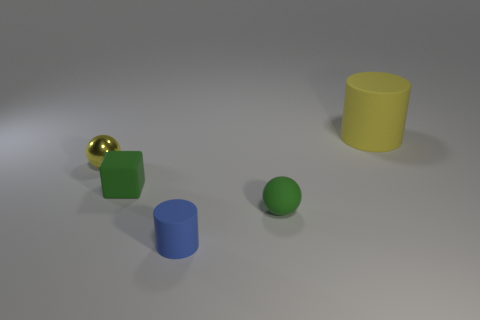There is a small thing that is behind the tiny blue matte thing and to the right of the small cube; what material is it made of?
Offer a very short reply. Rubber. What is the size of the other matte object that is the same shape as the blue matte object?
Ensure brevity in your answer.  Large. Do the green matte thing that is right of the blue cylinder and the small thing to the left of the tiny green rubber block have the same shape?
Offer a terse response. Yes. There is a tiny green object that is on the right side of the cylinder on the left side of the large matte object; what number of tiny green rubber objects are on the left side of it?
Ensure brevity in your answer.  1. The thing that is in front of the tiny sphere that is in front of the yellow thing in front of the big yellow matte thing is made of what material?
Offer a very short reply. Rubber. Is the material of the small green thing to the left of the tiny green rubber ball the same as the tiny yellow object?
Keep it short and to the point. No. What number of matte cubes have the same size as the blue object?
Provide a succinct answer. 1. Is the number of yellow objects on the left side of the yellow rubber cylinder greater than the number of big cylinders left of the small matte sphere?
Provide a succinct answer. Yes. Are there any large things that have the same shape as the small blue thing?
Your answer should be compact. Yes. What size is the cylinder that is in front of the tiny metallic ball that is on the left side of the matte cube?
Your answer should be very brief. Small. 